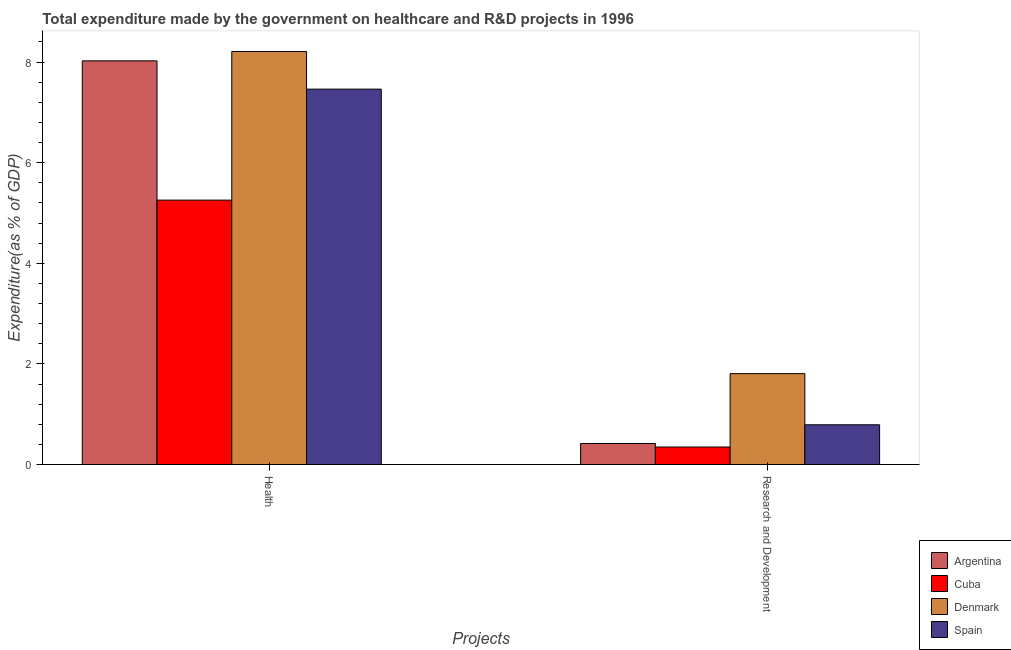Are the number of bars on each tick of the X-axis equal?
Offer a terse response. Yes. What is the label of the 2nd group of bars from the left?
Your answer should be compact. Research and Development. What is the expenditure in healthcare in Denmark?
Make the answer very short. 8.21. Across all countries, what is the maximum expenditure in healthcare?
Your answer should be compact. 8.21. Across all countries, what is the minimum expenditure in healthcare?
Offer a terse response. 5.26. In which country was the expenditure in healthcare minimum?
Your response must be concise. Cuba. What is the total expenditure in healthcare in the graph?
Keep it short and to the point. 28.96. What is the difference between the expenditure in healthcare in Denmark and that in Argentina?
Provide a short and direct response. 0.19. What is the difference between the expenditure in healthcare in Argentina and the expenditure in r&d in Denmark?
Ensure brevity in your answer.  6.22. What is the average expenditure in r&d per country?
Your response must be concise. 0.84. What is the difference between the expenditure in r&d and expenditure in healthcare in Spain?
Provide a succinct answer. -6.67. In how many countries, is the expenditure in r&d greater than 0.4 %?
Make the answer very short. 3. What is the ratio of the expenditure in healthcare in Denmark to that in Spain?
Your answer should be compact. 1.1. In how many countries, is the expenditure in r&d greater than the average expenditure in r&d taken over all countries?
Your answer should be very brief. 1. How many countries are there in the graph?
Your response must be concise. 4. What is the difference between two consecutive major ticks on the Y-axis?
Your response must be concise. 2. Where does the legend appear in the graph?
Your answer should be very brief. Bottom right. How are the legend labels stacked?
Provide a short and direct response. Vertical. What is the title of the graph?
Offer a very short reply. Total expenditure made by the government on healthcare and R&D projects in 1996. Does "Togo" appear as one of the legend labels in the graph?
Provide a succinct answer. No. What is the label or title of the X-axis?
Keep it short and to the point. Projects. What is the label or title of the Y-axis?
Provide a short and direct response. Expenditure(as % of GDP). What is the Expenditure(as % of GDP) of Argentina in Health?
Offer a very short reply. 8.02. What is the Expenditure(as % of GDP) in Cuba in Health?
Keep it short and to the point. 5.26. What is the Expenditure(as % of GDP) in Denmark in Health?
Your answer should be very brief. 8.21. What is the Expenditure(as % of GDP) in Spain in Health?
Your answer should be very brief. 7.46. What is the Expenditure(as % of GDP) in Argentina in Research and Development?
Give a very brief answer. 0.42. What is the Expenditure(as % of GDP) of Cuba in Research and Development?
Your response must be concise. 0.35. What is the Expenditure(as % of GDP) of Denmark in Research and Development?
Offer a terse response. 1.81. What is the Expenditure(as % of GDP) in Spain in Research and Development?
Your answer should be compact. 0.79. Across all Projects, what is the maximum Expenditure(as % of GDP) in Argentina?
Offer a terse response. 8.02. Across all Projects, what is the maximum Expenditure(as % of GDP) of Cuba?
Keep it short and to the point. 5.26. Across all Projects, what is the maximum Expenditure(as % of GDP) of Denmark?
Your answer should be compact. 8.21. Across all Projects, what is the maximum Expenditure(as % of GDP) of Spain?
Ensure brevity in your answer.  7.46. Across all Projects, what is the minimum Expenditure(as % of GDP) in Argentina?
Give a very brief answer. 0.42. Across all Projects, what is the minimum Expenditure(as % of GDP) of Cuba?
Offer a terse response. 0.35. Across all Projects, what is the minimum Expenditure(as % of GDP) of Denmark?
Your answer should be very brief. 1.81. Across all Projects, what is the minimum Expenditure(as % of GDP) in Spain?
Ensure brevity in your answer.  0.79. What is the total Expenditure(as % of GDP) in Argentina in the graph?
Your answer should be very brief. 8.44. What is the total Expenditure(as % of GDP) in Cuba in the graph?
Provide a short and direct response. 5.6. What is the total Expenditure(as % of GDP) in Denmark in the graph?
Offer a terse response. 10.02. What is the total Expenditure(as % of GDP) in Spain in the graph?
Give a very brief answer. 8.25. What is the difference between the Expenditure(as % of GDP) in Argentina in Health and that in Research and Development?
Give a very brief answer. 7.61. What is the difference between the Expenditure(as % of GDP) of Cuba in Health and that in Research and Development?
Your answer should be compact. 4.91. What is the difference between the Expenditure(as % of GDP) of Denmark in Health and that in Research and Development?
Your answer should be very brief. 6.4. What is the difference between the Expenditure(as % of GDP) of Spain in Health and that in Research and Development?
Your response must be concise. 6.67. What is the difference between the Expenditure(as % of GDP) of Argentina in Health and the Expenditure(as % of GDP) of Cuba in Research and Development?
Give a very brief answer. 7.68. What is the difference between the Expenditure(as % of GDP) in Argentina in Health and the Expenditure(as % of GDP) in Denmark in Research and Development?
Offer a terse response. 6.22. What is the difference between the Expenditure(as % of GDP) of Argentina in Health and the Expenditure(as % of GDP) of Spain in Research and Development?
Your answer should be very brief. 7.24. What is the difference between the Expenditure(as % of GDP) in Cuba in Health and the Expenditure(as % of GDP) in Denmark in Research and Development?
Ensure brevity in your answer.  3.45. What is the difference between the Expenditure(as % of GDP) in Cuba in Health and the Expenditure(as % of GDP) in Spain in Research and Development?
Your answer should be compact. 4.47. What is the difference between the Expenditure(as % of GDP) in Denmark in Health and the Expenditure(as % of GDP) in Spain in Research and Development?
Make the answer very short. 7.42. What is the average Expenditure(as % of GDP) of Argentina per Projects?
Offer a very short reply. 4.22. What is the average Expenditure(as % of GDP) of Cuba per Projects?
Provide a short and direct response. 2.8. What is the average Expenditure(as % of GDP) in Denmark per Projects?
Provide a short and direct response. 5.01. What is the average Expenditure(as % of GDP) in Spain per Projects?
Your response must be concise. 4.13. What is the difference between the Expenditure(as % of GDP) of Argentina and Expenditure(as % of GDP) of Cuba in Health?
Offer a very short reply. 2.77. What is the difference between the Expenditure(as % of GDP) in Argentina and Expenditure(as % of GDP) in Denmark in Health?
Your response must be concise. -0.19. What is the difference between the Expenditure(as % of GDP) in Argentina and Expenditure(as % of GDP) in Spain in Health?
Make the answer very short. 0.56. What is the difference between the Expenditure(as % of GDP) in Cuba and Expenditure(as % of GDP) in Denmark in Health?
Make the answer very short. -2.96. What is the difference between the Expenditure(as % of GDP) of Cuba and Expenditure(as % of GDP) of Spain in Health?
Your answer should be compact. -2.21. What is the difference between the Expenditure(as % of GDP) in Denmark and Expenditure(as % of GDP) in Spain in Health?
Give a very brief answer. 0.75. What is the difference between the Expenditure(as % of GDP) in Argentina and Expenditure(as % of GDP) in Cuba in Research and Development?
Ensure brevity in your answer.  0.07. What is the difference between the Expenditure(as % of GDP) of Argentina and Expenditure(as % of GDP) of Denmark in Research and Development?
Provide a succinct answer. -1.39. What is the difference between the Expenditure(as % of GDP) in Argentina and Expenditure(as % of GDP) in Spain in Research and Development?
Offer a terse response. -0.37. What is the difference between the Expenditure(as % of GDP) in Cuba and Expenditure(as % of GDP) in Denmark in Research and Development?
Ensure brevity in your answer.  -1.46. What is the difference between the Expenditure(as % of GDP) in Cuba and Expenditure(as % of GDP) in Spain in Research and Development?
Your answer should be very brief. -0.44. What is the difference between the Expenditure(as % of GDP) of Denmark and Expenditure(as % of GDP) of Spain in Research and Development?
Ensure brevity in your answer.  1.02. What is the ratio of the Expenditure(as % of GDP) in Argentina in Health to that in Research and Development?
Offer a very short reply. 19.22. What is the ratio of the Expenditure(as % of GDP) of Cuba in Health to that in Research and Development?
Your answer should be very brief. 15.13. What is the ratio of the Expenditure(as % of GDP) in Denmark in Health to that in Research and Development?
Provide a succinct answer. 4.55. What is the ratio of the Expenditure(as % of GDP) of Spain in Health to that in Research and Development?
Your answer should be very brief. 9.45. What is the difference between the highest and the second highest Expenditure(as % of GDP) in Argentina?
Offer a terse response. 7.61. What is the difference between the highest and the second highest Expenditure(as % of GDP) in Cuba?
Keep it short and to the point. 4.91. What is the difference between the highest and the second highest Expenditure(as % of GDP) in Denmark?
Offer a very short reply. 6.4. What is the difference between the highest and the second highest Expenditure(as % of GDP) in Spain?
Give a very brief answer. 6.67. What is the difference between the highest and the lowest Expenditure(as % of GDP) of Argentina?
Provide a succinct answer. 7.61. What is the difference between the highest and the lowest Expenditure(as % of GDP) in Cuba?
Your response must be concise. 4.91. What is the difference between the highest and the lowest Expenditure(as % of GDP) of Denmark?
Your answer should be compact. 6.4. What is the difference between the highest and the lowest Expenditure(as % of GDP) of Spain?
Ensure brevity in your answer.  6.67. 